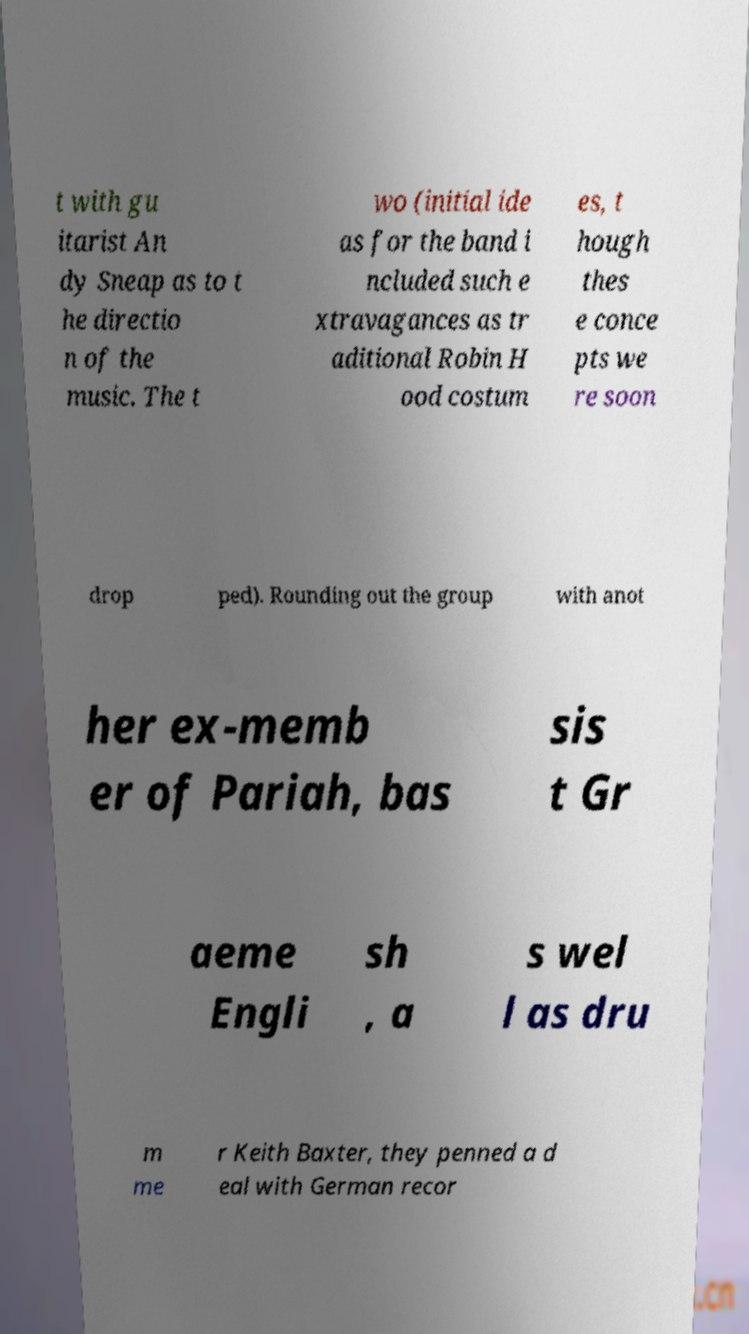Could you assist in decoding the text presented in this image and type it out clearly? t with gu itarist An dy Sneap as to t he directio n of the music. The t wo (initial ide as for the band i ncluded such e xtravagances as tr aditional Robin H ood costum es, t hough thes e conce pts we re soon drop ped). Rounding out the group with anot her ex-memb er of Pariah, bas sis t Gr aeme Engli sh , a s wel l as dru m me r Keith Baxter, they penned a d eal with German recor 